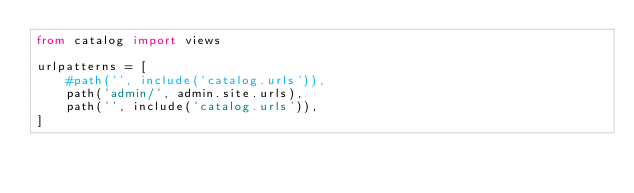Convert code to text. <code><loc_0><loc_0><loc_500><loc_500><_Python_>from catalog import views

urlpatterns = [
    #path('', include('catalog.urls')),
    path('admin/', admin.site.urls),
    path('', include('catalog.urls')),
]
</code> 